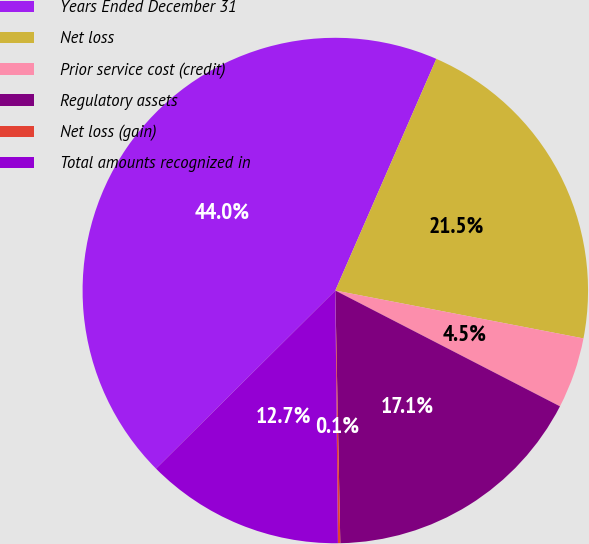<chart> <loc_0><loc_0><loc_500><loc_500><pie_chart><fcel>Years Ended December 31<fcel>Net loss<fcel>Prior service cost (credit)<fcel>Regulatory assets<fcel>Net loss (gain)<fcel>Total amounts recognized in<nl><fcel>43.99%<fcel>21.49%<fcel>4.54%<fcel>17.11%<fcel>0.15%<fcel>12.72%<nl></chart> 